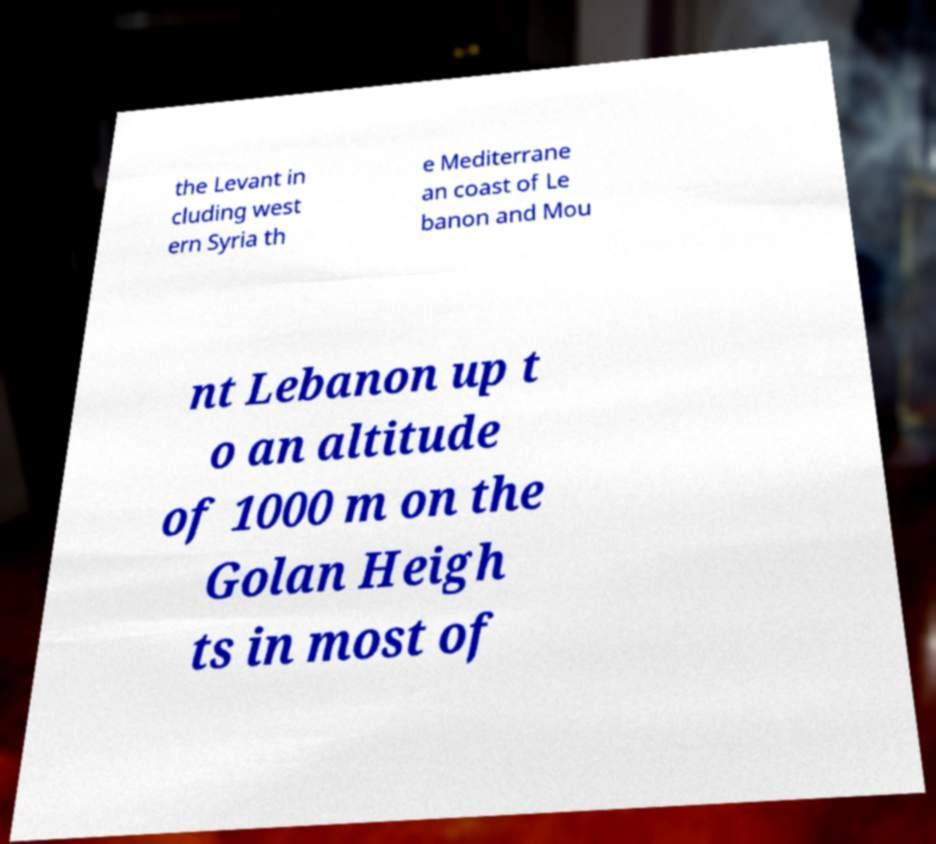Please read and relay the text visible in this image. What does it say? the Levant in cluding west ern Syria th e Mediterrane an coast of Le banon and Mou nt Lebanon up t o an altitude of 1000 m on the Golan Heigh ts in most of 